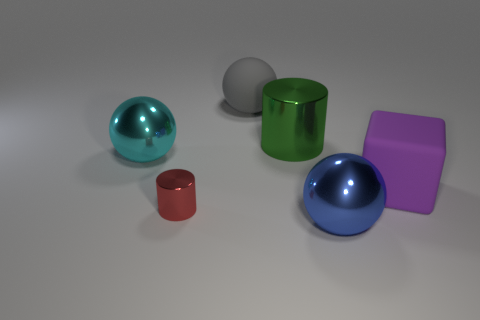There is a big sphere that is the same material as the cyan object; what is its color? The large sphere that appears to be made from the same glossy material as the smaller cyan object is also cyan in color, demonstrating a consistent and reflective surface finish. 